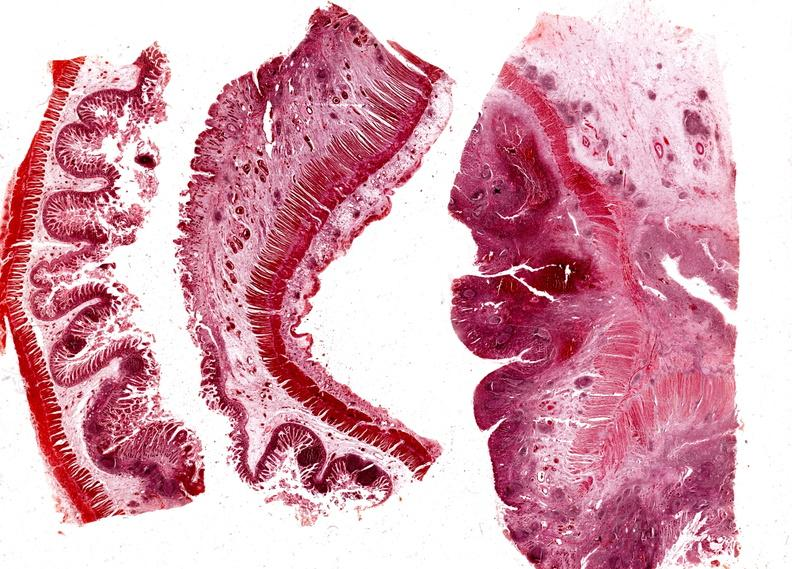what does this image show?
Answer the question using a single word or phrase. Colon 